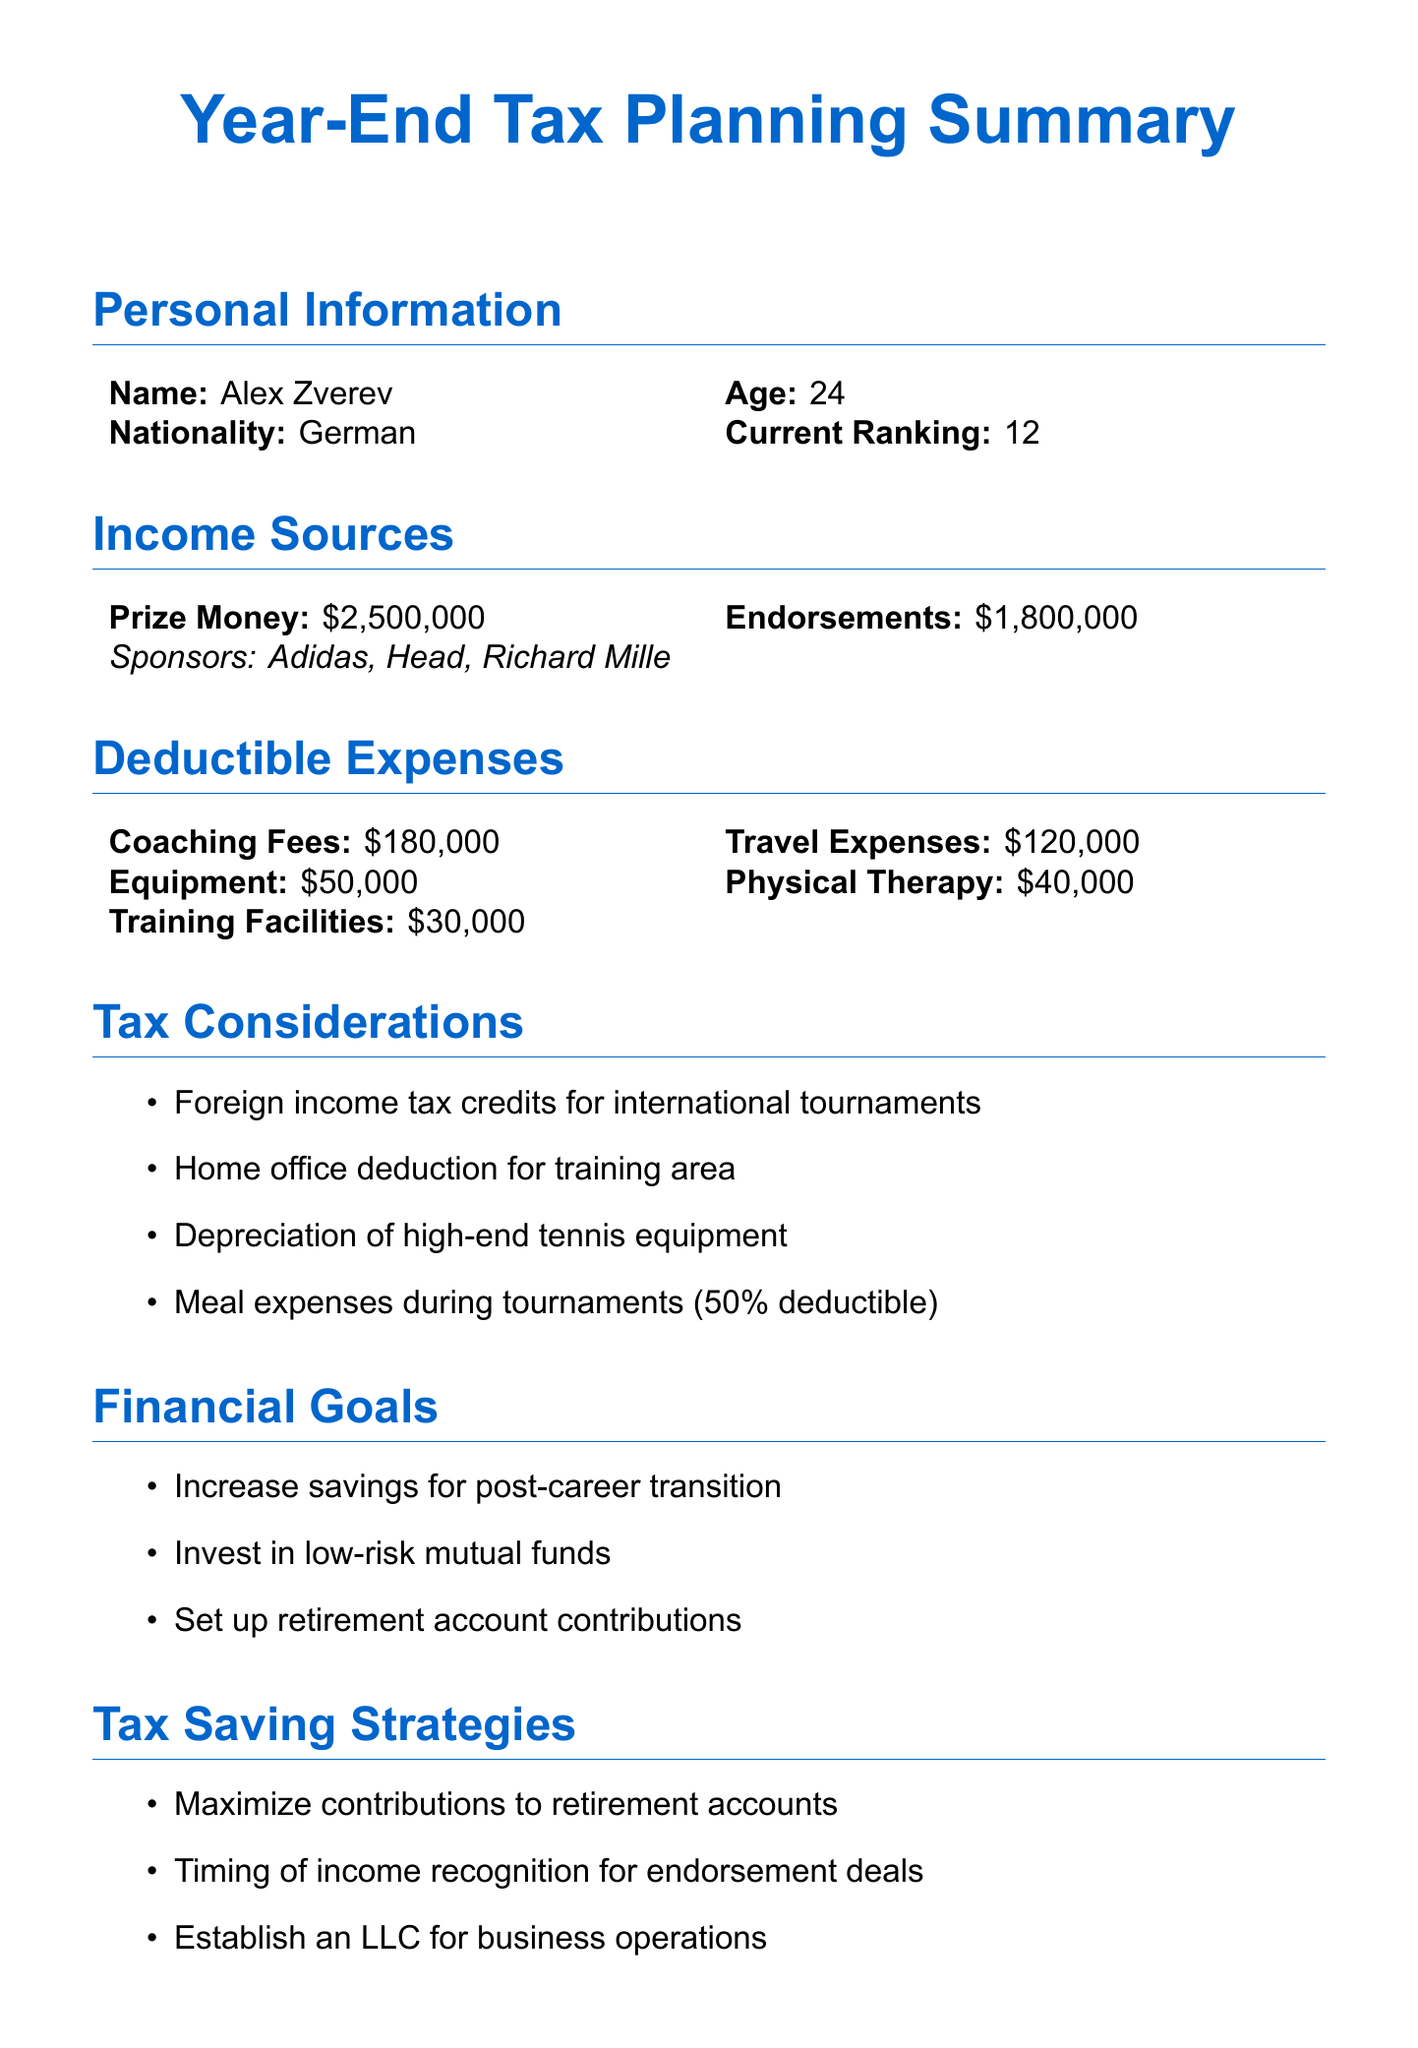What is Alex Zverev's current ranking? The current ranking of Alex Zverev is mentioned in the personal information section of the document.
Answer: 12 What is the total amount of prize money earned? The total amount of prize money earned is specified in the income sources section of the document.
Answer: 2500000 Who is Alex Zverev's coach? The document lists the coaching fees and specifies the name of the coach in the deductible expenses section.
Answer: Ivan Lendl What is the amount of travel expenses? The travel expenses incurred are detailed in the deductible expenses section of the document.
Answer: 120000 What percentage of meal expenses during tournaments is deductible? The document mentions the deduction rate for meal expenses directly in the tax considerations section.
Answer: 50% What are the financial goals stated in the report? The financial goals are listed in the document and outline the aspirations of Alex Zverev for his future financial management.
Answer: Increase savings for post-career transition, Invest in low-risk mutual funds, Set up retirement account contributions What is one tax saving strategy included in the document? The tax saving strategies are explicitly listed in the document, highlighting approaches for reducing taxable income.
Answer: Maximize contributions to retirement accounts How much was spent on physical therapy? The amount spent on physical therapy is specified in the deductible expenses section of the report.
Answer: 40000 What are the sponsors listed for endorsements? The sponsors associated with endorsements for Alex Zverev are mentioned in the income sources section of the document.
Answer: Adidas, Head, Richard Mille 